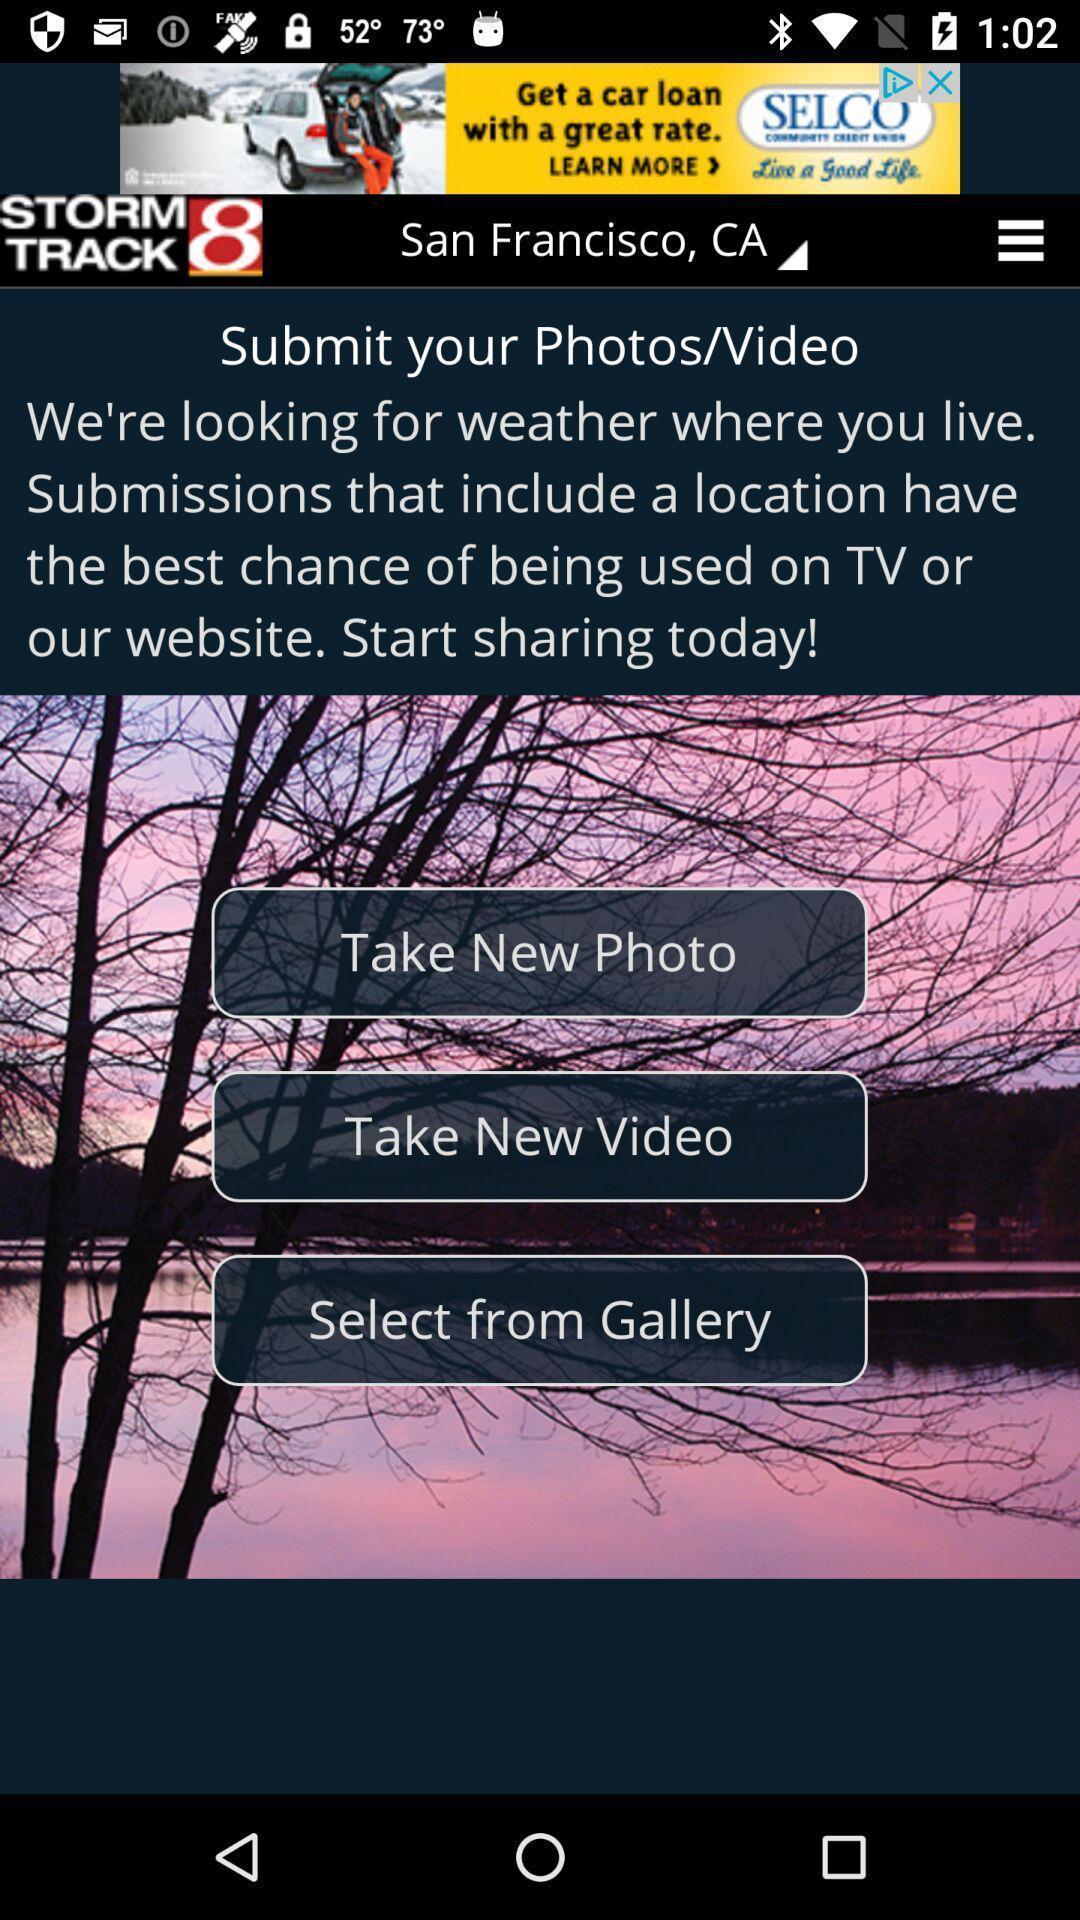Provide a textual representation of this image. Weather application displayed to take new photo and other options. 